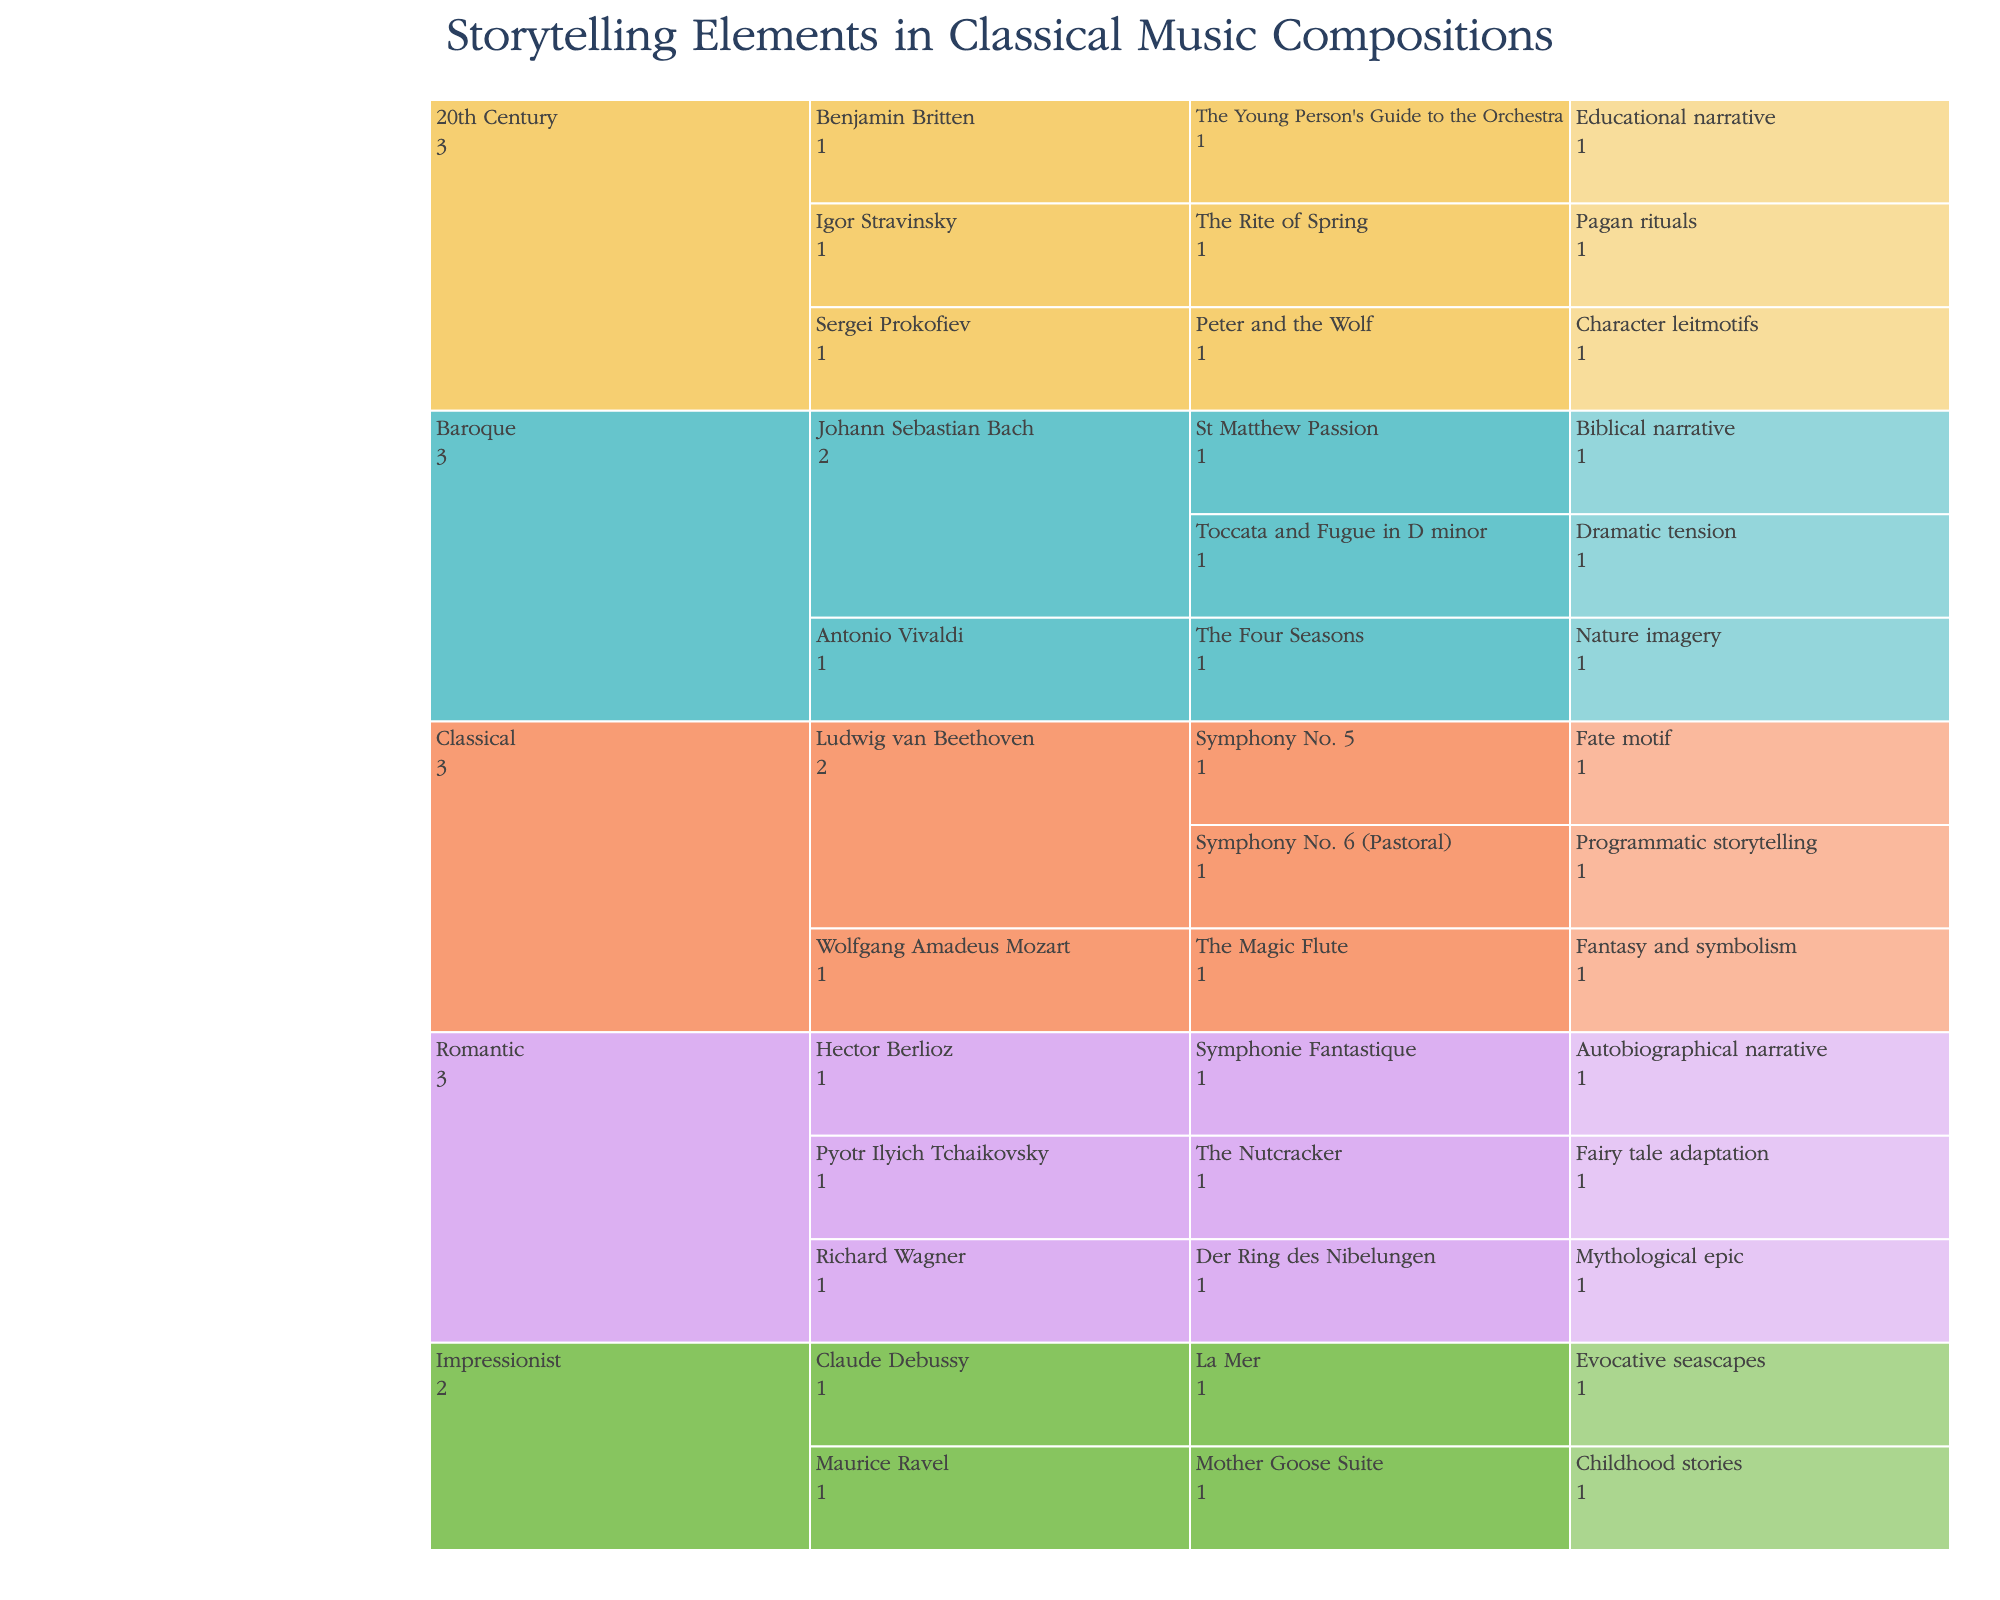What's the title of the Icicle Chart? The title is usually displayed prominently at the top of the chart. Since it is stated in the code snippet, look at the title section mentioned in the figure specifications.
Answer: "Storytelling Elements in Classical Music Compositions" Which era features the composition "The Four Seasons"? Trace the path of "The Four Seasons" in the Icicle chart starting from the composition heading up to the era level.
Answer: Baroque How many composers are listed in the Romantic era? Under the Romantic era node, count the distinct composers listed.
Answer: Three (Hector Berlioz, Richard Wagner, Pyotr Ilyich Tchaikovsky) What storytelling element is associated with "Symphony No. 5" by Beethoven? Follow down the path from Beethoven's "Symphony No. 5" to its storytelling element.
Answer: Fate motif How many compositions are there in the Baroque era? Under the Baroque era node, count all the compositions listed for its composers.
Answer: Three (Toccata and Fugue in D minor, St Matthew Passion, The Four Seasons) Compare the number of compositions by Bach and Beethoven. Who has more? Count the number of compositions listed under Bach and Beethoven. Compare the totals to determine who has more.
Answer: Bach has more (Bach: 2, Beethoven: 2; therefore, equal) What storytelling element is shared by compositions from the 20th Century era? Look for common elements under the nodes for the 20th Century compositions.
Answer: Each composition has a unique storytelling element Which composer has a composition related to "Evocative seascapes"? Find the composition associated with "Evocative seascapes" and trace upward to identify the composer.
Answer: Claude Debussy Is there any storytelling element related to nature imagery other than in "The Four Seasons"? Check if any other compositions, outside of "The Four Seasons," have nature-related storytelling elements.
Answer: No 